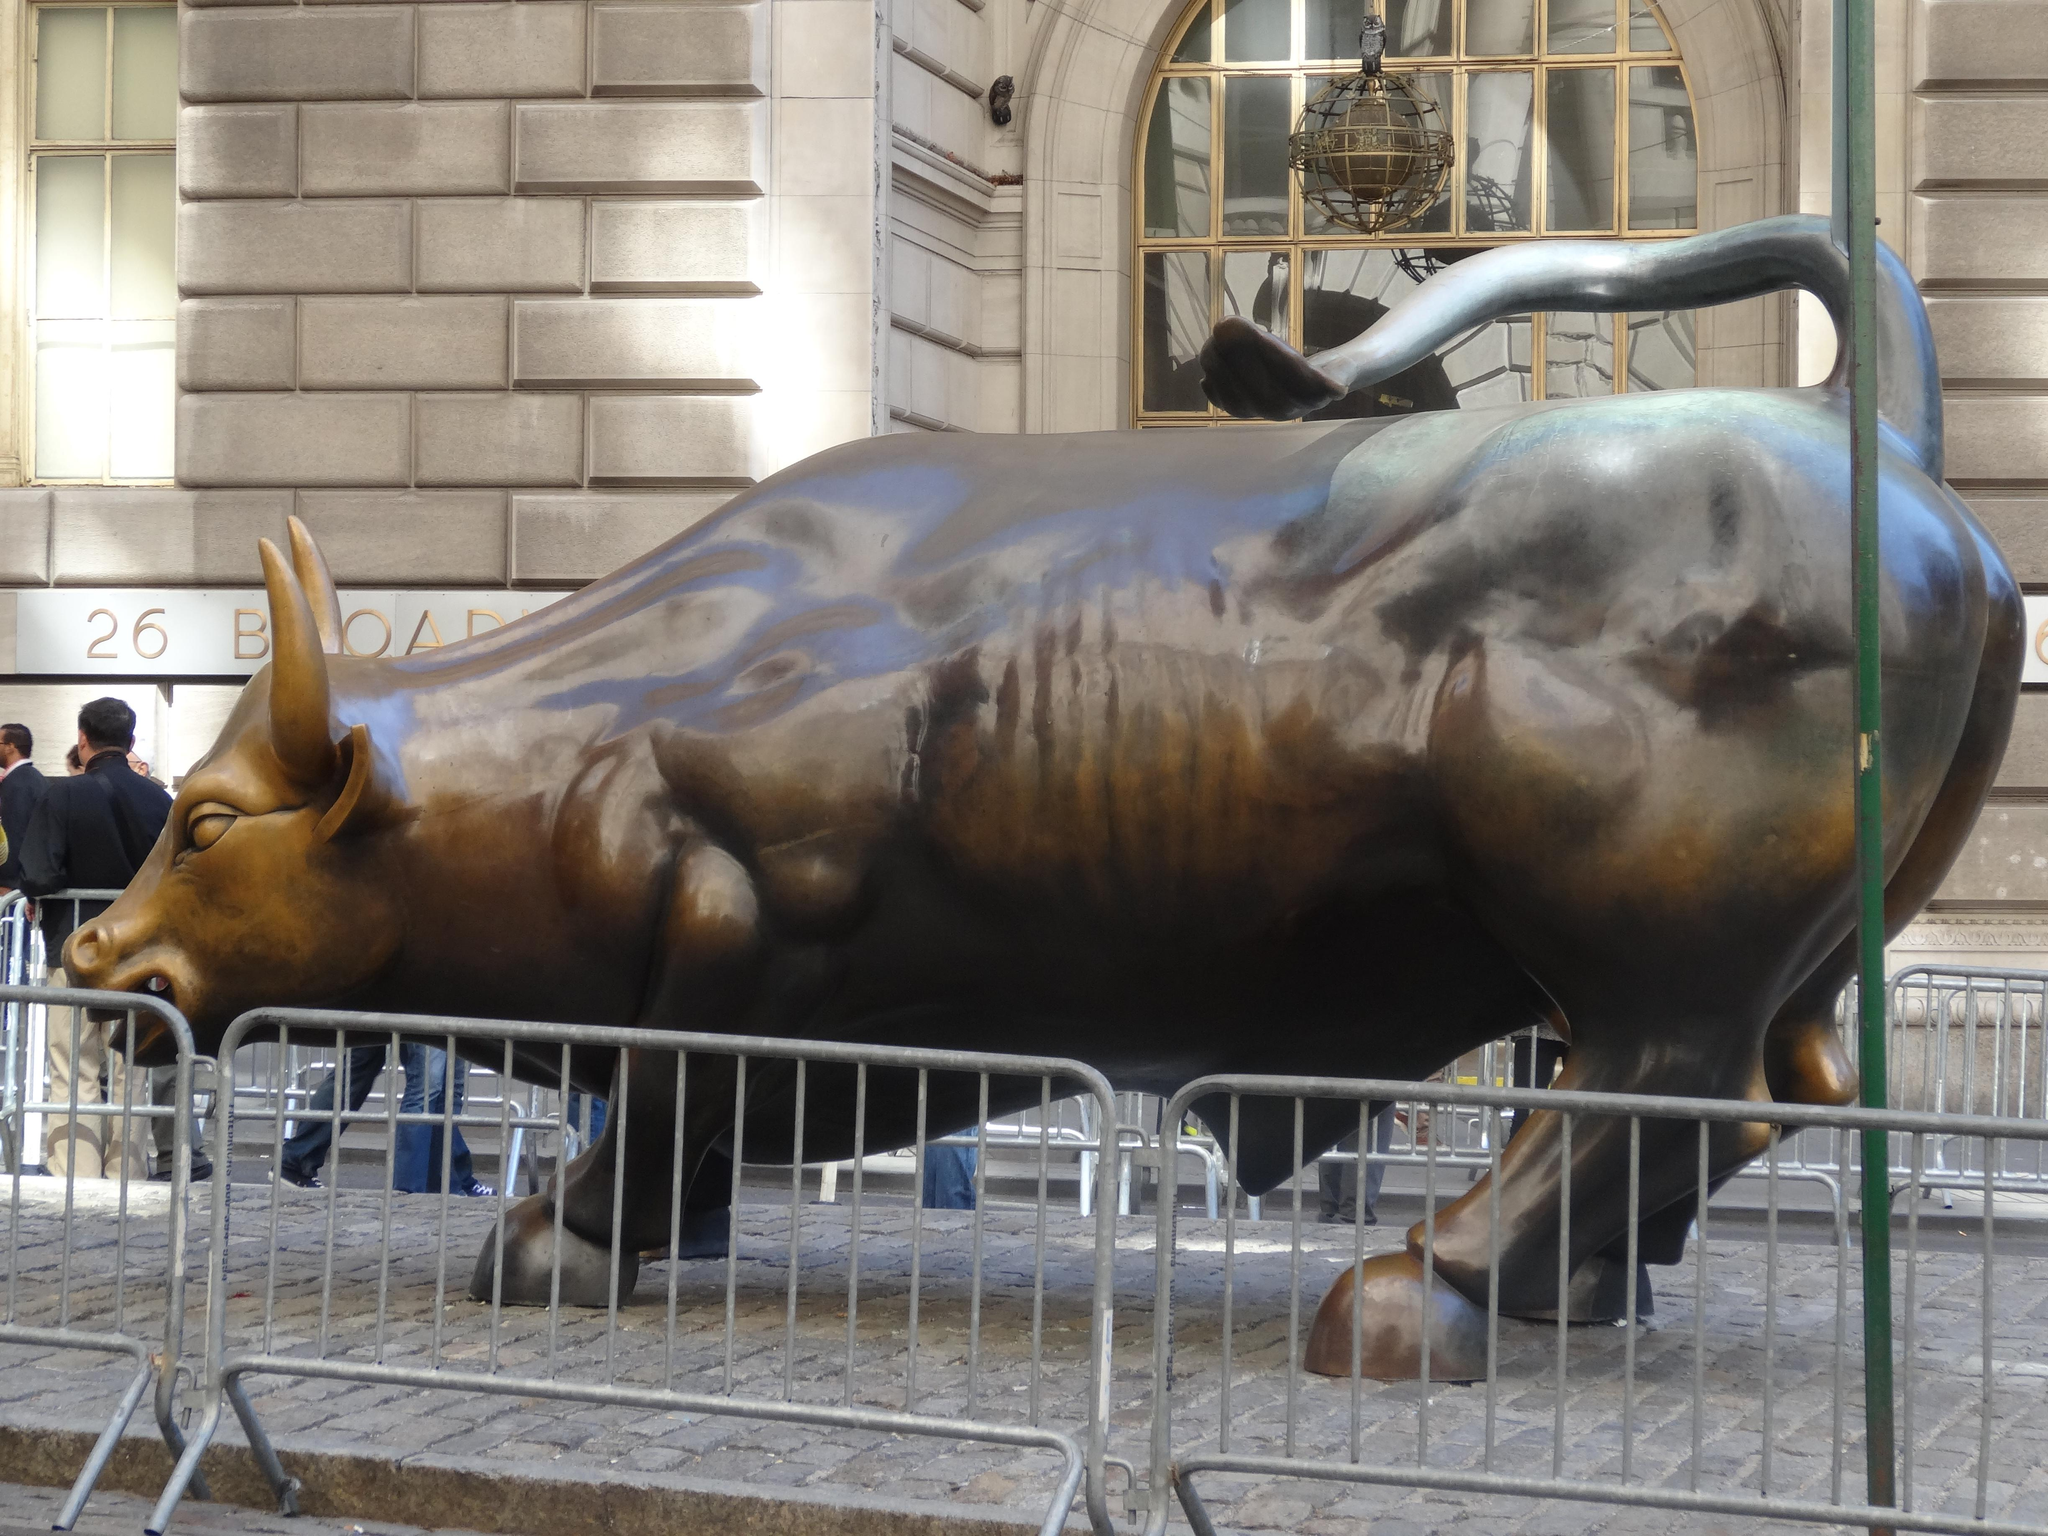What is the main subject of the image? There is a big sculpture of a bull in the image. How is the sculpture protected or contained? The sculpture is surrounded by a fence. What else can be seen in the image besides the sculpture? There is a group of people walking on the road and a building visible in the image. What type of punishment is being administered to the bull in the image? There is no punishment being administered to the bull in the image; it is a sculpture. What kind of market is depicted in the image? There is no market depicted in the image; it features a sculpture of a bull, a fence, a group of people walking on the road, and a building. 